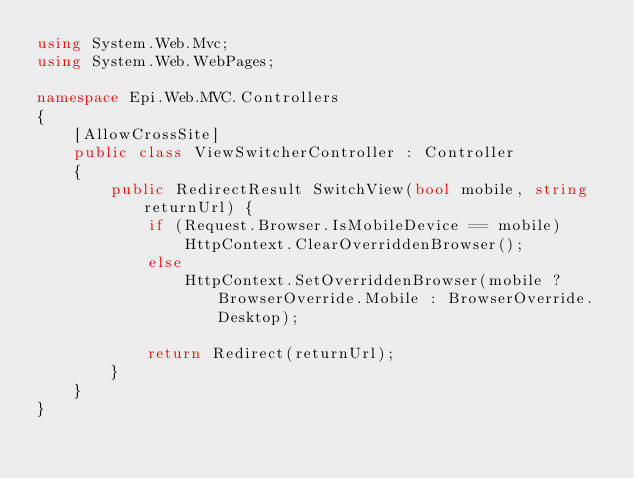<code> <loc_0><loc_0><loc_500><loc_500><_C#_>using System.Web.Mvc;
using System.Web.WebPages;

namespace Epi.Web.MVC.Controllers
{
	[AllowCrossSite]
	public class ViewSwitcherController : Controller
    {
        public RedirectResult SwitchView(bool mobile, string returnUrl) {
            if (Request.Browser.IsMobileDevice == mobile)
                HttpContext.ClearOverriddenBrowser();
            else
                HttpContext.SetOverriddenBrowser(mobile ? BrowserOverride.Mobile : BrowserOverride.Desktop);

            return Redirect(returnUrl);
        }
    }
}
</code> 